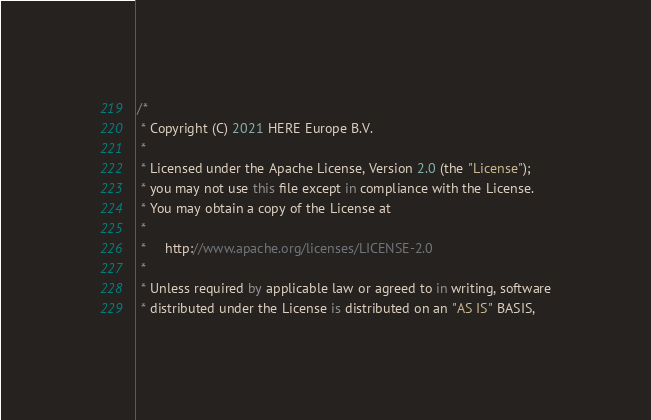<code> <loc_0><loc_0><loc_500><loc_500><_Kotlin_>/*
 * Copyright (C) 2021 HERE Europe B.V.
 *
 * Licensed under the Apache License, Version 2.0 (the "License");
 * you may not use this file except in compliance with the License.
 * You may obtain a copy of the License at
 *
 *     http://www.apache.org/licenses/LICENSE-2.0
 *
 * Unless required by applicable law or agreed to in writing, software
 * distributed under the License is distributed on an "AS IS" BASIS,</code> 